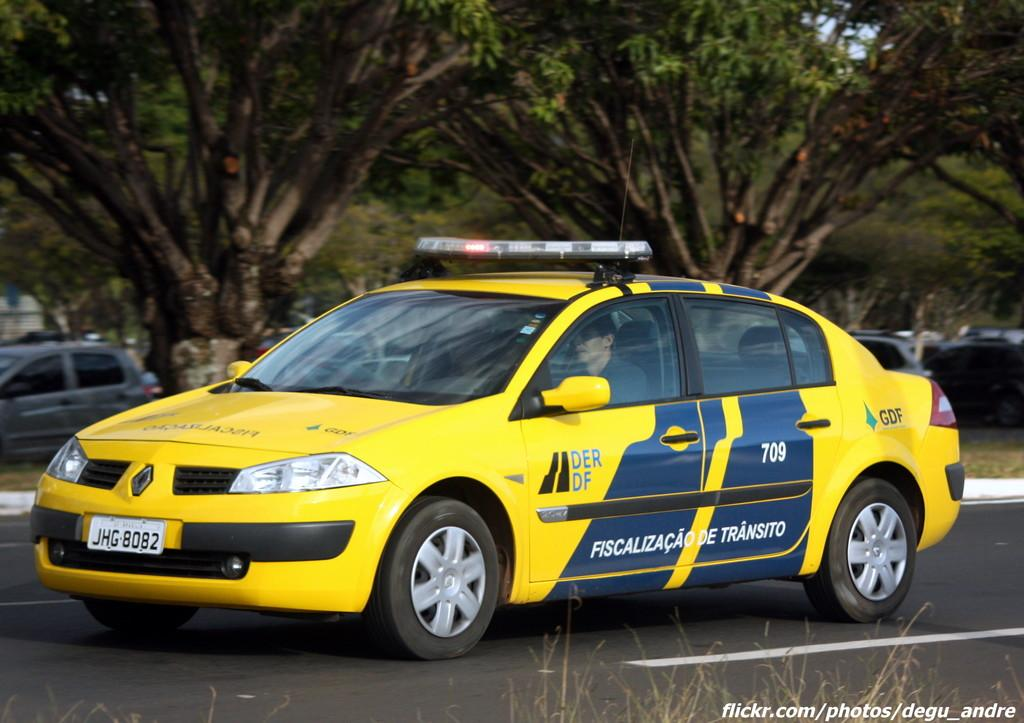<image>
Share a concise interpretation of the image provided. A yellow and blue car has a license plate of JHG8082. 